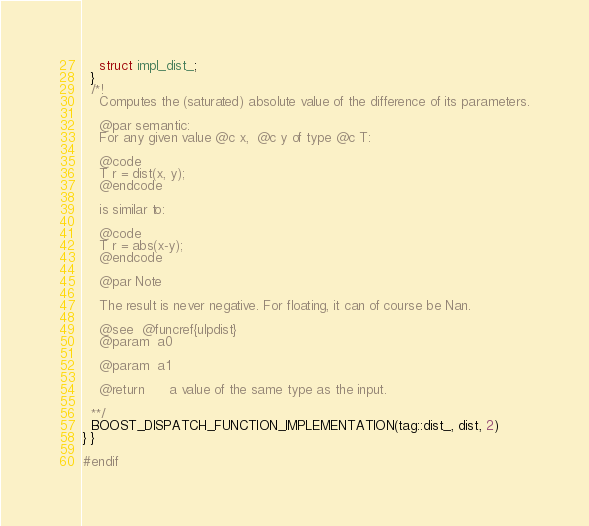<code> <loc_0><loc_0><loc_500><loc_500><_C++_>    struct impl_dist_;
  }
  /*!
    Computes the (saturated) absolute value of the difference of its parameters.

    @par semantic:
    For any given value @c x,  @c y of type @c T:

    @code
    T r = dist(x, y);
    @endcode

    is similar to:

    @code
    T r = abs(x-y);
    @endcode

    @par Note

    The result is never negative. For floating, it can of course be Nan.

    @see  @funcref{ulpdist}
    @param  a0

    @param  a1

    @return      a value of the same type as the input.

  **/
  BOOST_DISPATCH_FUNCTION_IMPLEMENTATION(tag::dist_, dist, 2)
} }

#endif
</code> 